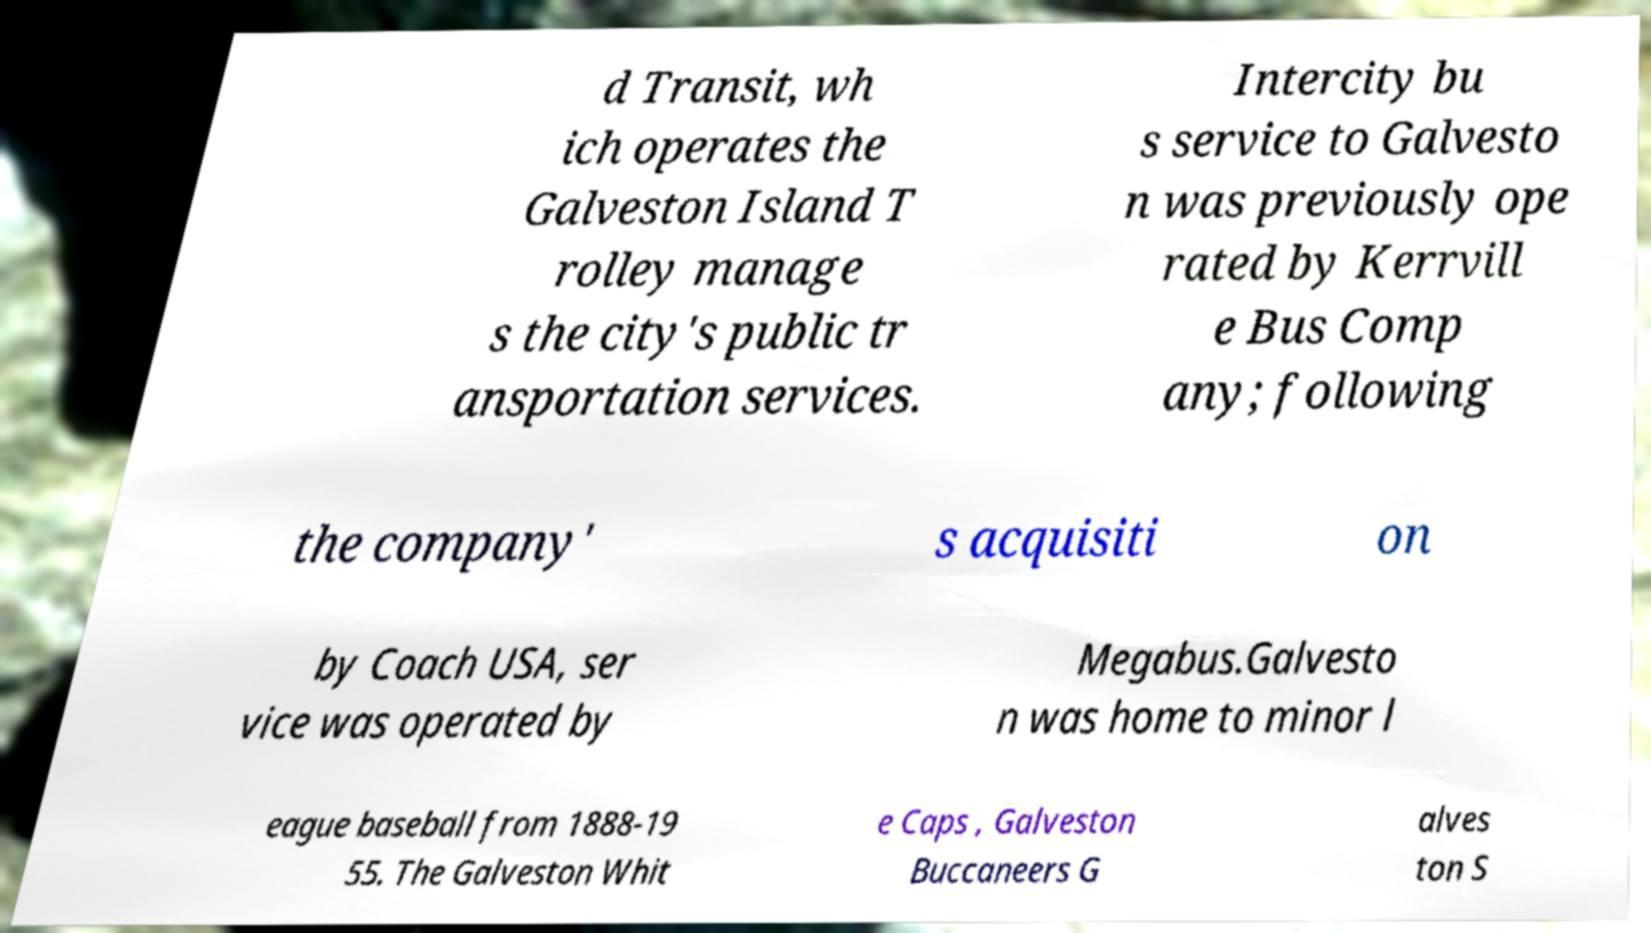There's text embedded in this image that I need extracted. Can you transcribe it verbatim? d Transit, wh ich operates the Galveston Island T rolley manage s the city's public tr ansportation services. Intercity bu s service to Galvesto n was previously ope rated by Kerrvill e Bus Comp any; following the company' s acquisiti on by Coach USA, ser vice was operated by Megabus.Galvesto n was home to minor l eague baseball from 1888-19 55. The Galveston Whit e Caps , Galveston Buccaneers G alves ton S 